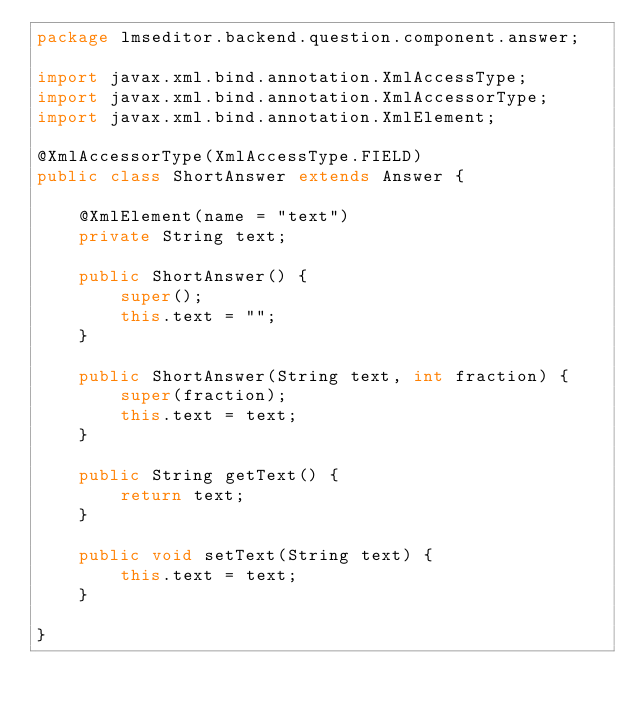<code> <loc_0><loc_0><loc_500><loc_500><_Java_>package lmseditor.backend.question.component.answer;

import javax.xml.bind.annotation.XmlAccessType;
import javax.xml.bind.annotation.XmlAccessorType;
import javax.xml.bind.annotation.XmlElement;

@XmlAccessorType(XmlAccessType.FIELD)
public class ShortAnswer extends Answer {

    @XmlElement(name = "text")
    private String text;

    public ShortAnswer() {
        super();
        this.text = "";
    }

    public ShortAnswer(String text, int fraction) {
        super(fraction);
        this.text = text;
    }

    public String getText() {
        return text;
    }

    public void setText(String text) {
        this.text = text;
    }

}
</code> 